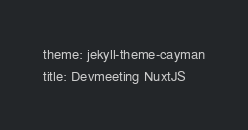Convert code to text. <code><loc_0><loc_0><loc_500><loc_500><_YAML_>theme: jekyll-theme-cayman
title: Devmeeting NuxtJS
</code> 